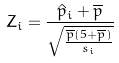<formula> <loc_0><loc_0><loc_500><loc_500>Z _ { i } = \frac { \hat { p } _ { i } + \overline { p } } { \sqrt { \frac { \overline { p } ( 5 + \overline { p } ) } { s _ { i } } } }</formula> 